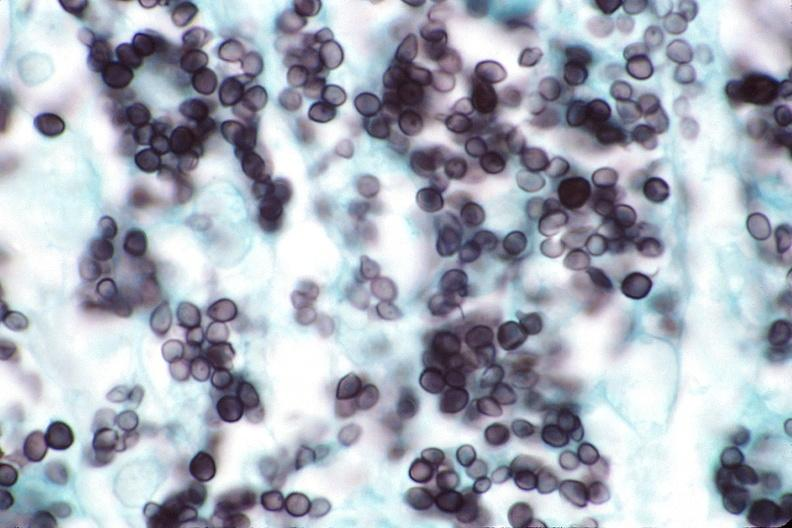do hemorrhage associated with placental abruption stain?
Answer the question using a single word or phrase. No 